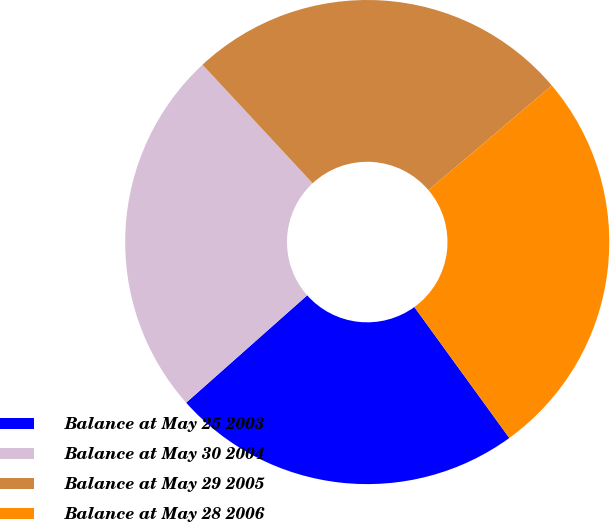Convert chart to OTSL. <chart><loc_0><loc_0><loc_500><loc_500><pie_chart><fcel>Balance at May 25 2003<fcel>Balance at May 30 2004<fcel>Balance at May 29 2005<fcel>Balance at May 28 2006<nl><fcel>23.44%<fcel>24.64%<fcel>25.72%<fcel>26.21%<nl></chart> 